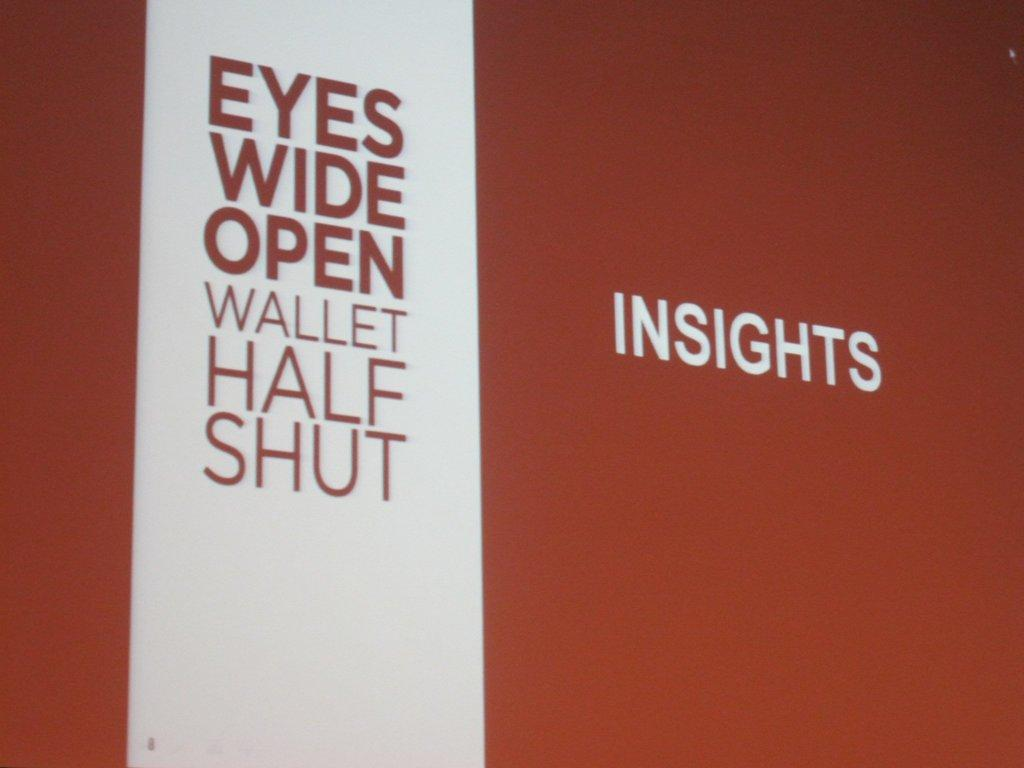Provide a one-sentence caption for the provided image. A large sign on an orange background titled Insights. 